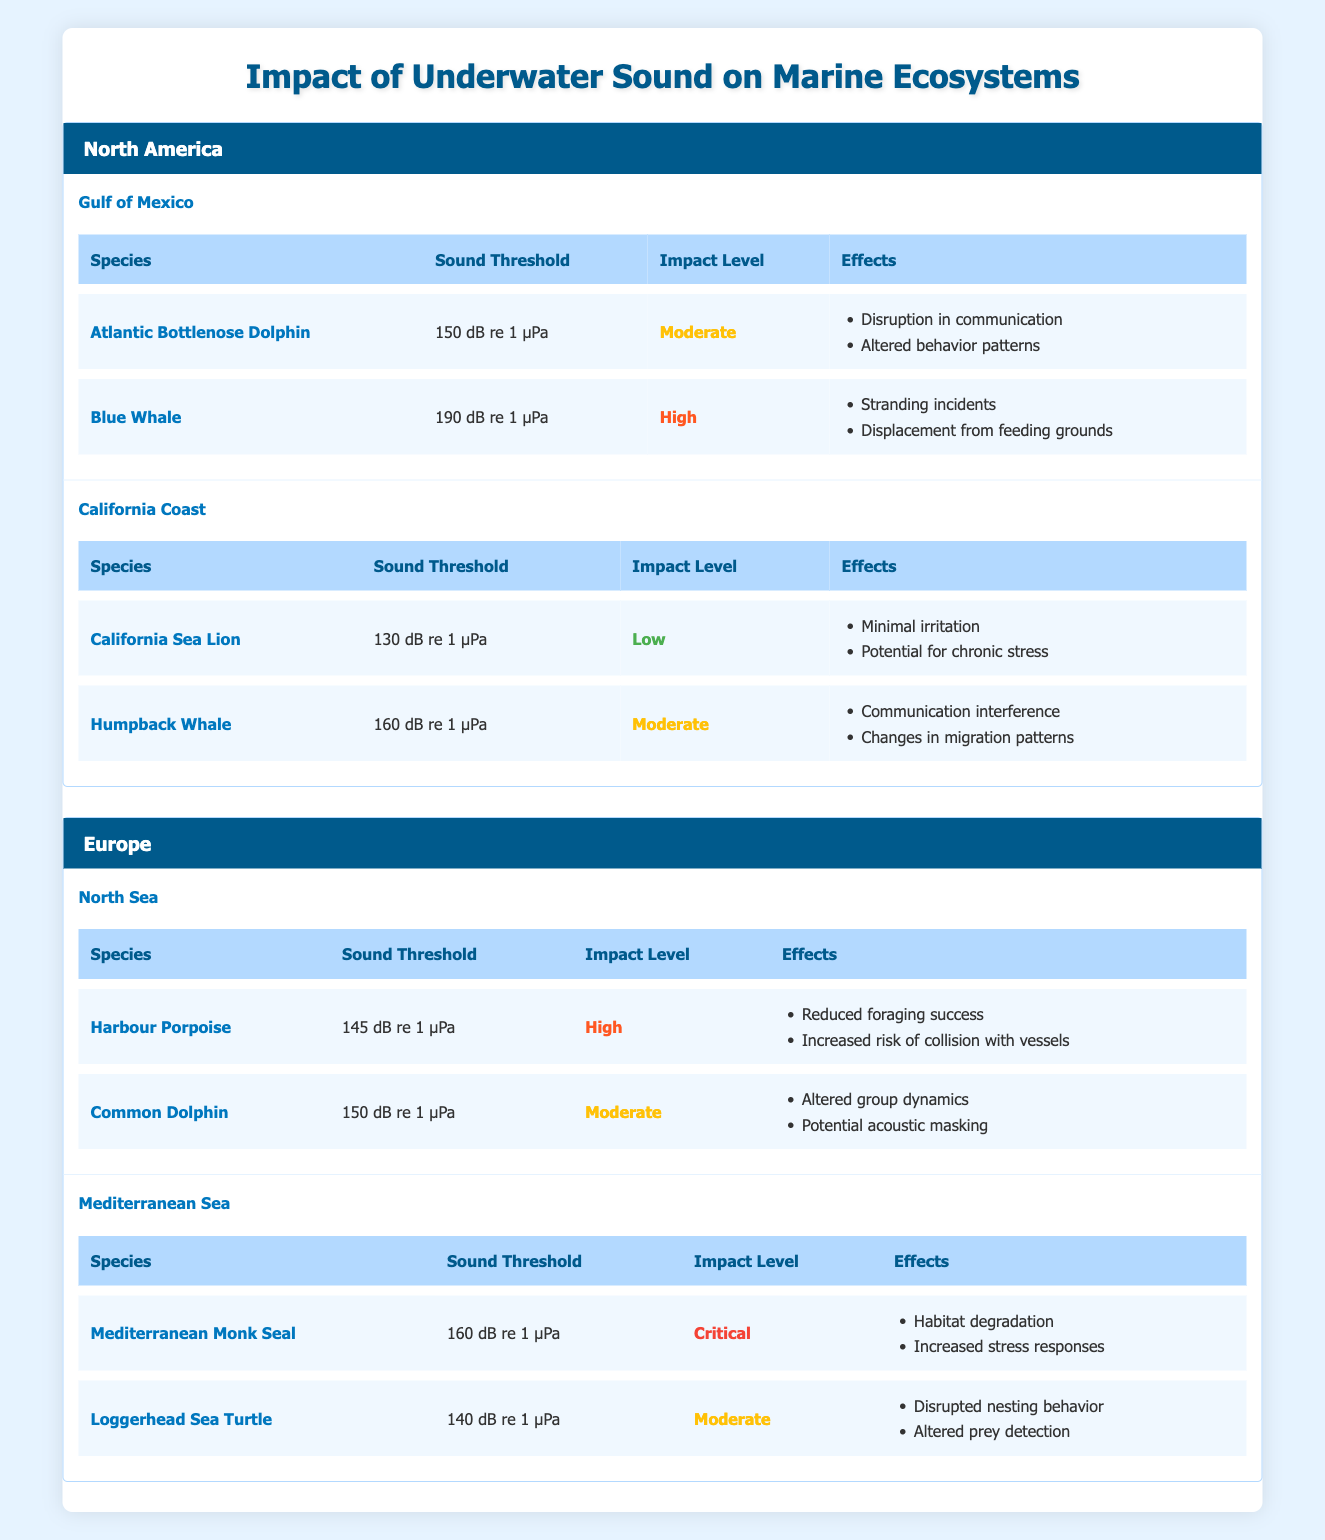What species in the North Sea has the highest sound threshold? From the North Sea region in the table, we can see that the Harbour Porpoise has a sound threshold of 145 dB re 1 µPa, while the Common Dolphin has a sound threshold of 150 dB re 1 µPa. The Common Dolphin has a higher threshold than the Harbour Porpoise.
Answer: Common Dolphin Which species has the lowest impact level in the Gulf of Mexico? In the Gulf of Mexico region, two species are listed: Atlantic Bottlenose Dolphin (Moderate) and Blue Whale (High). The Atlantic Bottlenose Dolphin has the lowest impact level compared to the Blue Whale.
Answer: Atlantic Bottlenose Dolphin Are there any species with a critical impact level in North America? Review the impact levels for species in the North American regions. The Gulf of Mexico has Atlantic Bottlenose Dolphin (Moderate) and Blue Whale (High); California Coast has California Sea Lion (Low) and Humpback Whale (Moderate). None of these have a critical impact level.
Answer: No What are the effects of noise on the Mediterranean Monk Seal? The Mediterranean Monk Seal has a critical impact level, and the effects are listed as habitat degradation and increased stress responses. These details can be found under the Mediterranean Sea section of the table.
Answer: Habitat degradation, increased stress responses Which region has the most species with a moderate impact level? In North America, Gulf of Mexico has one species (Atlantic Bottlenose Dolphin) and one (High) for Blue Whale. California Coast has the California Sea Lion (Low) and Humpback Whale (Moderate). In Europe, North Sea has Common Dolphin (Moderate), while the Mediterranean has Loggerhead Sea Turtle (Moderate). Comparing the regions, it appears that Europe (specifically Mediterranean Sea and North Sea) has two species each with a moderate impact level.
Answer: Europe Is the Blue Whale affected by underwater sound, and if so, how? The Blue Whale in the Gulf of Mexico has a high impact level due to sound, and the effects are stranding incidents and displacement from feeding grounds, indicating a serious concern for this species regarding noise pollution.
Answer: Yes, stranding incidents and displacement from feeding grounds How many species in total are listed for the California Coast? The California Coast region includes two species: California Sea Lion and Humpback Whale. The table explicitly lists these two under the California Coast sub-region.
Answer: 2 What is the average sound threshold for species listed in Europe? In the North Sea, the sound threshold values are 145 dB (Harbour Porpoise) and 150 dB (Common Dolphin), and in the Mediterranean Sea, they are 160 dB (Mediterranean Monk Seal) and 140 dB (Loggerhead Sea Turtle). To find the average, we first sum these values: 145 + 150 + 160 + 140 = 595. We then divide by the number of species, which is 4. Hence, 595/4 = 148.75.
Answer: 148.75 dB re 1 µPa What effect does underwater sound have on the Loggerhead Sea Turtle? The Loggerhead Sea Turtle in the Mediterranean Sea is affected by a moderate impact level, with notable effects including disrupted nesting behavior and altered prey detection. These effects are stated in the table showing the impacts on these species due to sound pollution.
Answer: Disrupted nesting behavior, altered prey detection 